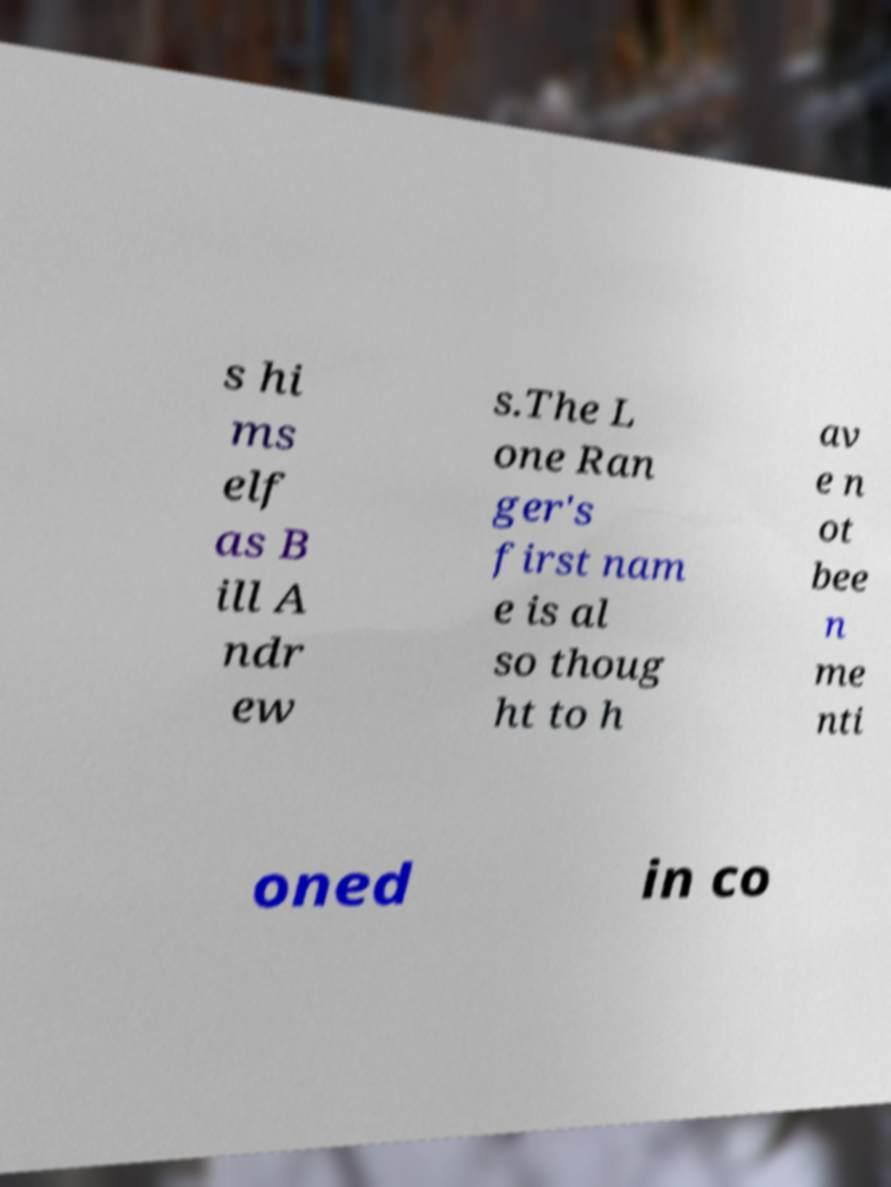There's text embedded in this image that I need extracted. Can you transcribe it verbatim? s hi ms elf as B ill A ndr ew s.The L one Ran ger's first nam e is al so thoug ht to h av e n ot bee n me nti oned in co 